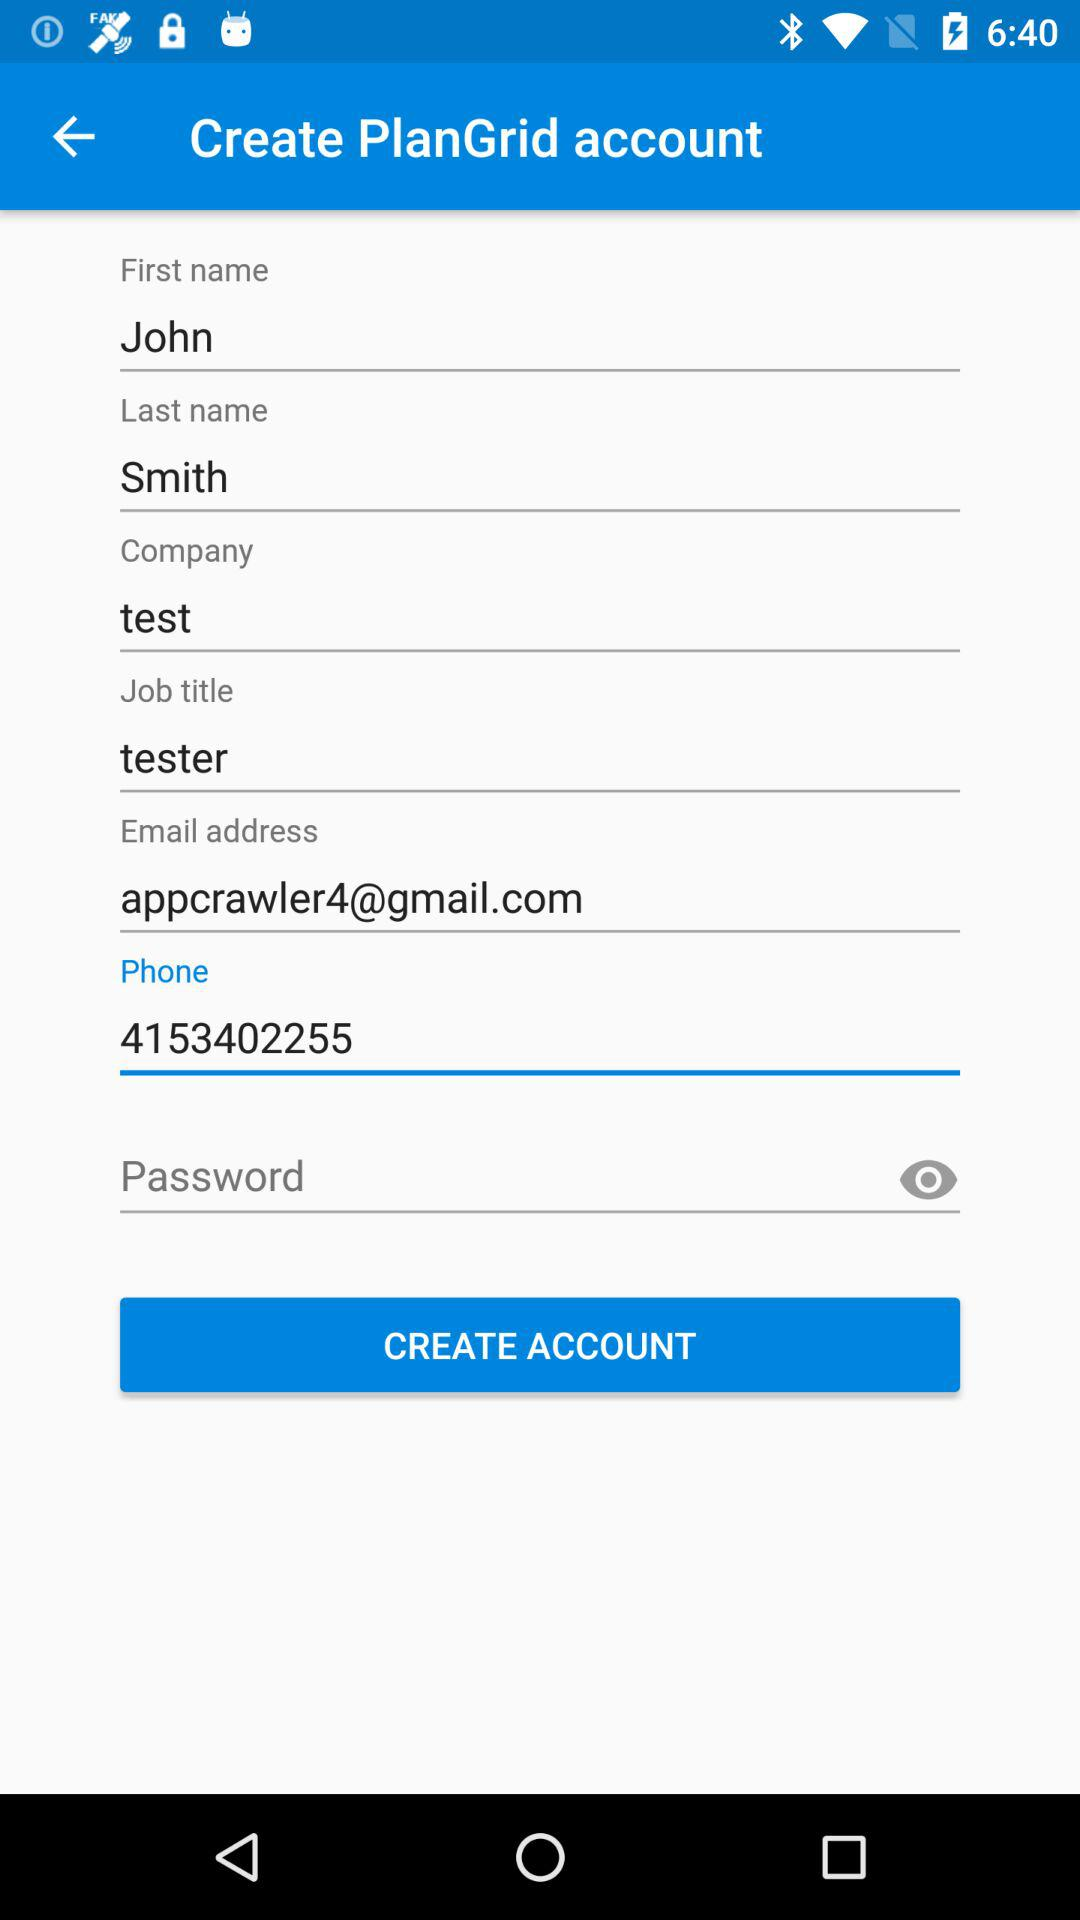What is the user's name in the employment profile? The user's name in the employment profile is John. 